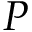<formula> <loc_0><loc_0><loc_500><loc_500>P</formula> 